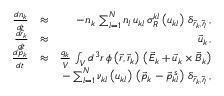Convert formula to latex. <formula><loc_0><loc_0><loc_500><loc_500>\begin{array} { r l r } { \frac { d n _ { k } } { d t } } & { \approx } & { - n _ { k } \, \sum _ { l = 1 } ^ { N } n _ { l } \, u _ { k l } \, \sigma _ { R } ^ { k l } \left ( u _ { k l } \right ) \, \delta _ { \vec { r } _ { k } , \vec { r } _ { l } } \, , } \\ { \frac { d \vec { r } _ { k } } { d t } } & { \approx } & { \vec { u } _ { k } \, , } \\ { \frac { d \vec { p } _ { k } } { d t } } & { \approx } & { \frac { q _ { k } } { V } \, \int _ { V } d ^ { 3 } r \, \phi \left ( \vec { r } , \vec { r } _ { k } \right ) \, \left ( \vec { E } _ { k } + \vec { u } _ { k } \times \vec { B } _ { k } \right ) } \\ & { - \sum _ { l = 1 } ^ { N } \nu _ { k l } \left ( u _ { k l } \right ) \, \left ( \vec { p } _ { k } - \vec { p } _ { k l } ^ { \, s } \right ) \, \delta _ { \vec { r } _ { k } , \vec { r } _ { l } } \, , } \end{array}</formula> 